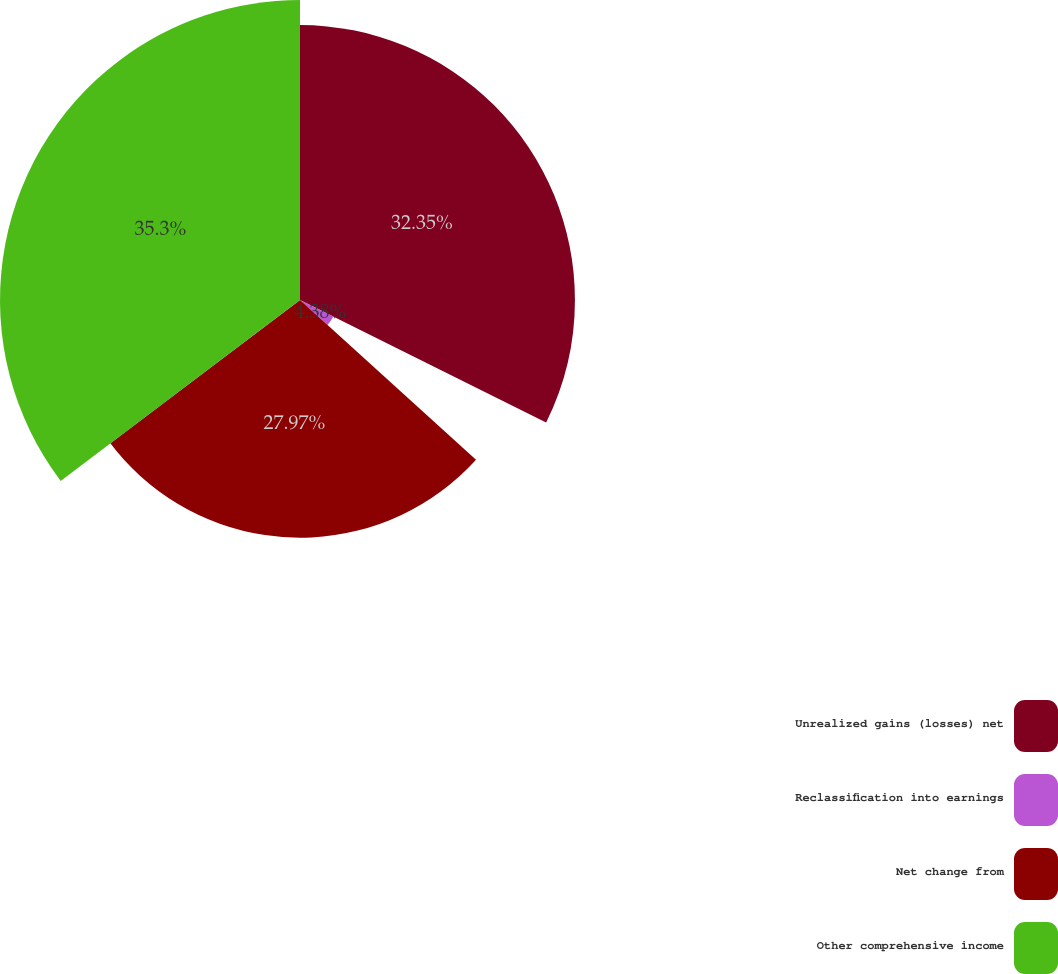<chart> <loc_0><loc_0><loc_500><loc_500><pie_chart><fcel>Unrealized gains (losses) net<fcel>Reclassification into earnings<fcel>Net change from<fcel>Other comprehensive income<nl><fcel>32.35%<fcel>4.38%<fcel>27.97%<fcel>35.3%<nl></chart> 